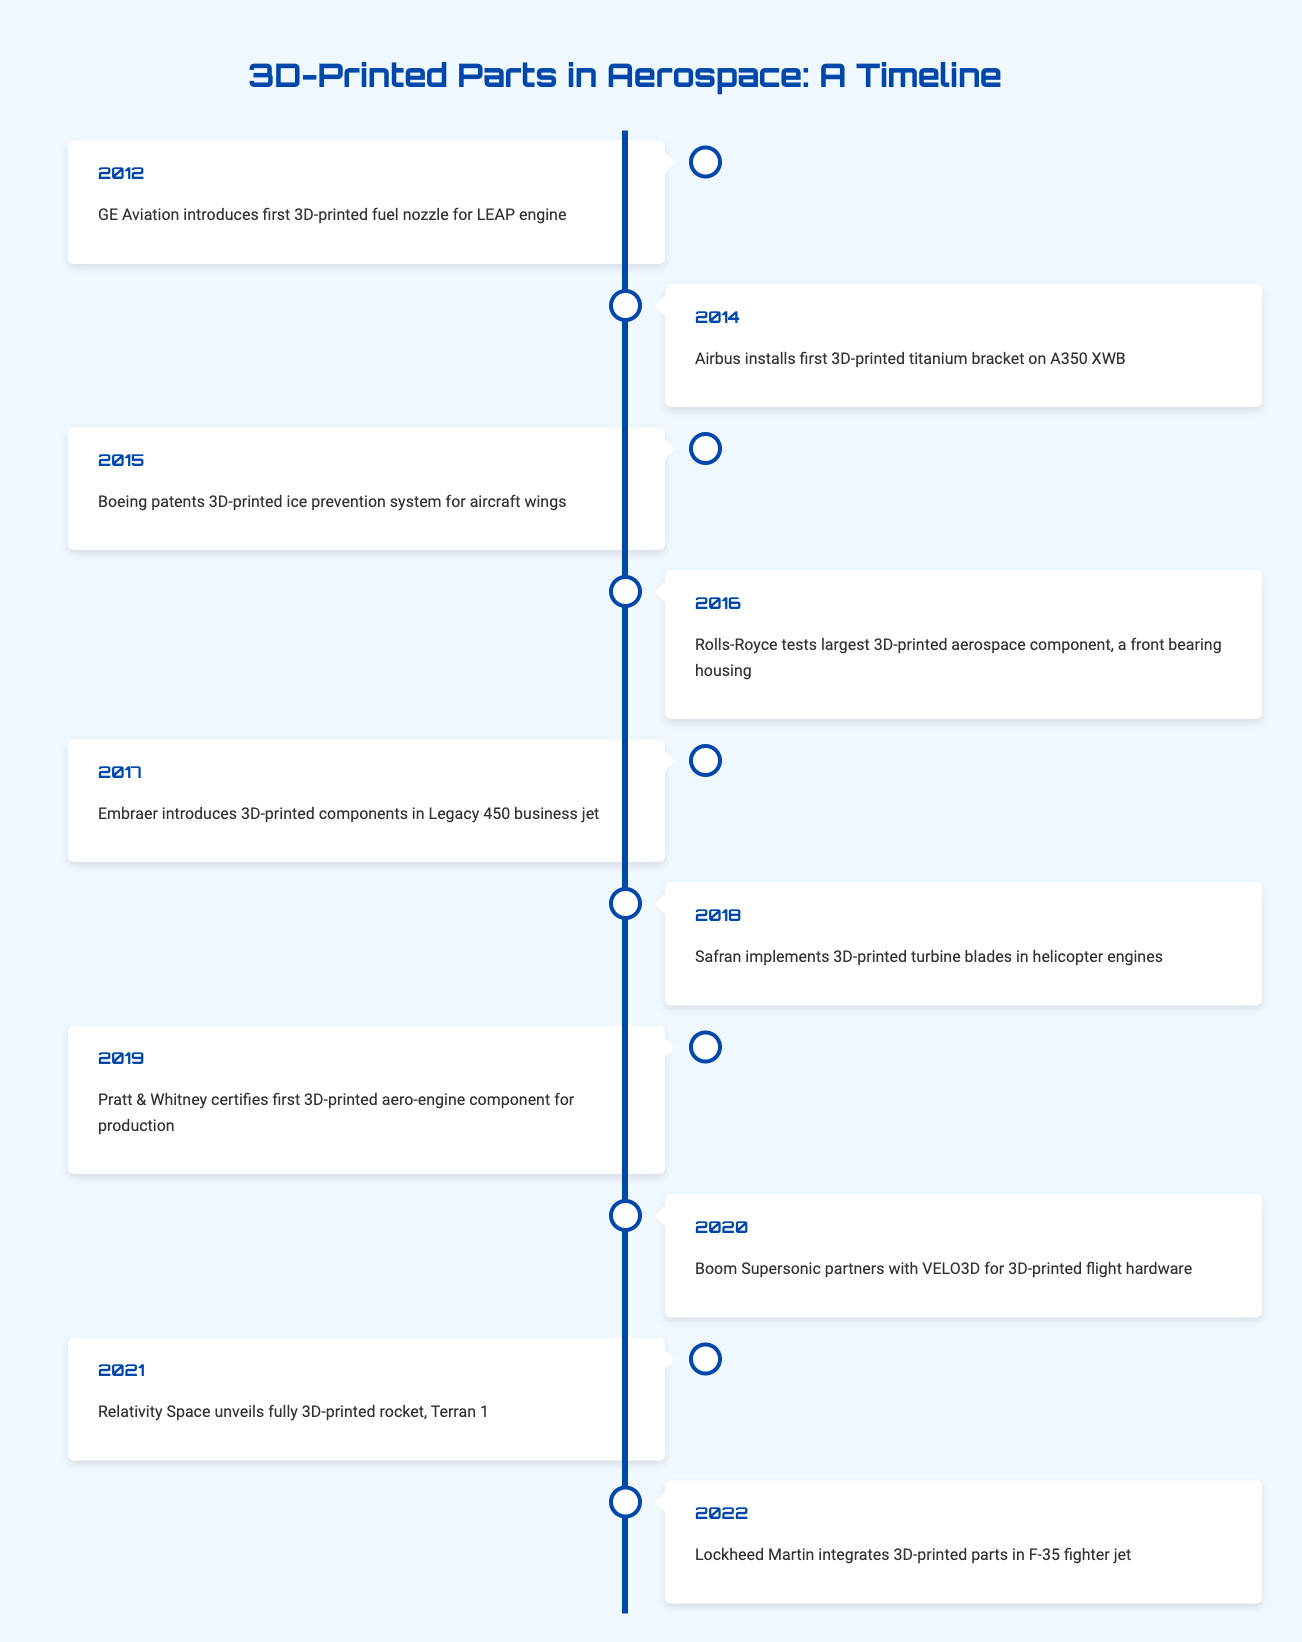What was the first event in the adoption of 3D-printed parts by aircraft manufacturers? The first event listed in the timeline table is from the year 2012, where GE Aviation introduced the first 3D-printed fuel nozzle for the LEAP engine.
Answer: GE Aviation introduces first 3D-printed fuel nozzle for LEAP engine Which aircraft manufacturer introduced a 3D-printed component in 2017? In the year 2017, the event states that Embraer introduced 3D-printed components in the Legacy 450 business jet.
Answer: Embraer How many events occurred in the timeline between 2015 and 2019? The events between 2015 and 2019 are listed as follows: 2015 (Boeing), 2016 (Rolls-Royce), 2017 (Embraer), 2018 (Safran), and 2019 (Pratt & Whitney), totaling 5 events.
Answer: 5 Did Lockheed Martin integrate 3D-printed parts into any aircraft before 2022? According to the table, Lockheed Martin integrated 3D-printed parts in 2022, so they did not do this before that year.
Answer: No What is the range of years during which the listed events occurred? Examining the timeline, the earliest event is from 2012 and the latest is from 2022. To find the range, we subtract the earliest year (2012) from the latest year (2022), resulting in a range of 10 years.
Answer: 10 years What is the total number of different aircraft manufacturers mentioned in the timeline? The unique manufacturers mentioned are GE Aviation, Airbus, Boeing, Rolls-Royce, Embraer, Safran, Pratt & Whitney, Boom Supersonic, Relativity Space, and Lockheed Martin—totaling 10 different manufacturers.
Answer: 10 In which year did Safran implement 3D-printed turbine blades? The timeline indicates that Safran implemented 3D-printed turbine blades in 2018.
Answer: 2018 Which event occurred immediately after Boeing's patent for a 3D-printed system? Following Boeing's patent in 2015, the next event is Rolls-Royce testing the largest 3D-printed aerospace component in 2016.
Answer: Rolls-Royce tests largest 3D-printed aerospace component in 2016 